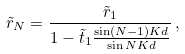<formula> <loc_0><loc_0><loc_500><loc_500>\tilde { r } _ { N } = \frac { \tilde { r } _ { 1 } } { 1 - \tilde { t } _ { 1 } \frac { \sin ( N - 1 ) K d } { \sin N K d } } \, ,</formula> 